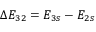Convert formula to latex. <formula><loc_0><loc_0><loc_500><loc_500>\Delta E _ { 3 2 } = E _ { 3 s } - E _ { 2 s }</formula> 